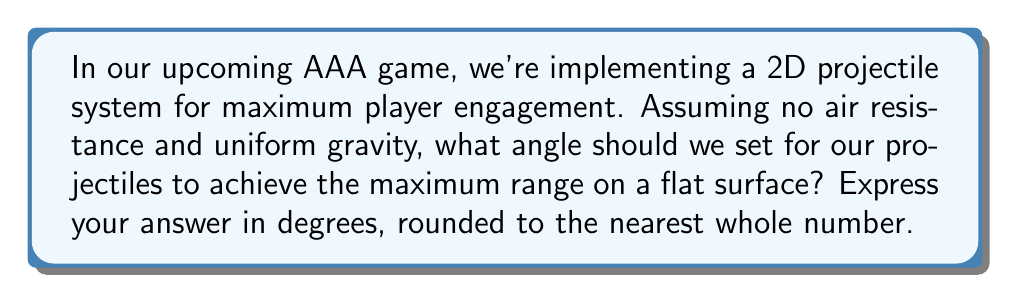Teach me how to tackle this problem. Let's approach this step-by-step:

1) In a 2D projectile motion, the range $R$ is given by the formula:

   $$R = \frac{v^2 \sin(2\theta)}{g}$$

   Where $v$ is the initial velocity, $\theta$ is the launch angle, and $g$ is the acceleration due to gravity.

2) To find the maximum range, we need to maximize $\sin(2\theta)$.

3) The sine function reaches its maximum value of 1 when its argument is 90°.

4) So, we want:

   $$2\theta = 90°$$

5) Solving for $\theta$:

   $$\theta = 45°$$

6) This result is independent of the initial velocity and gravity, making it universally applicable in our game engine.

7) Rounding to the nearest whole number isn't necessary in this case as 45° is already a whole number.

This 45° angle will ensure our projectiles reach the maximum possible range, creating more dynamic and engaging gameplay scenarios.
Answer: 45° 